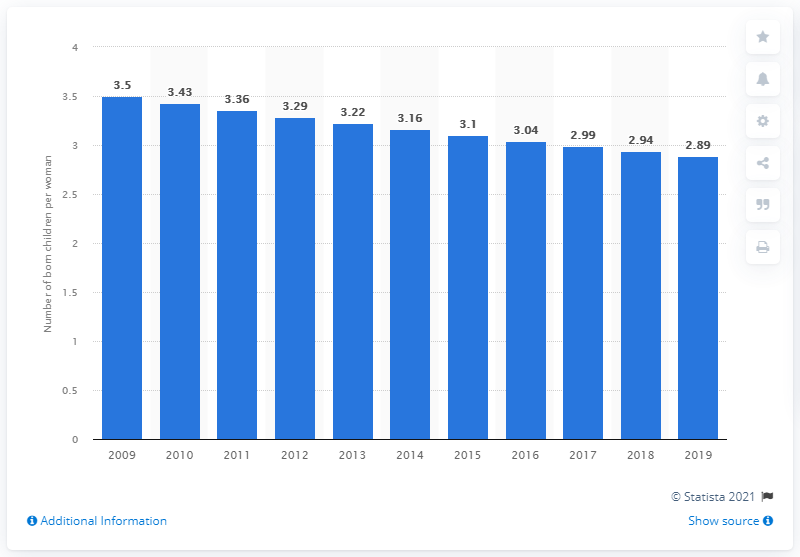Draw attention to some important aspects in this diagram. In 2019, Haiti's fertility rate was 2.89. 